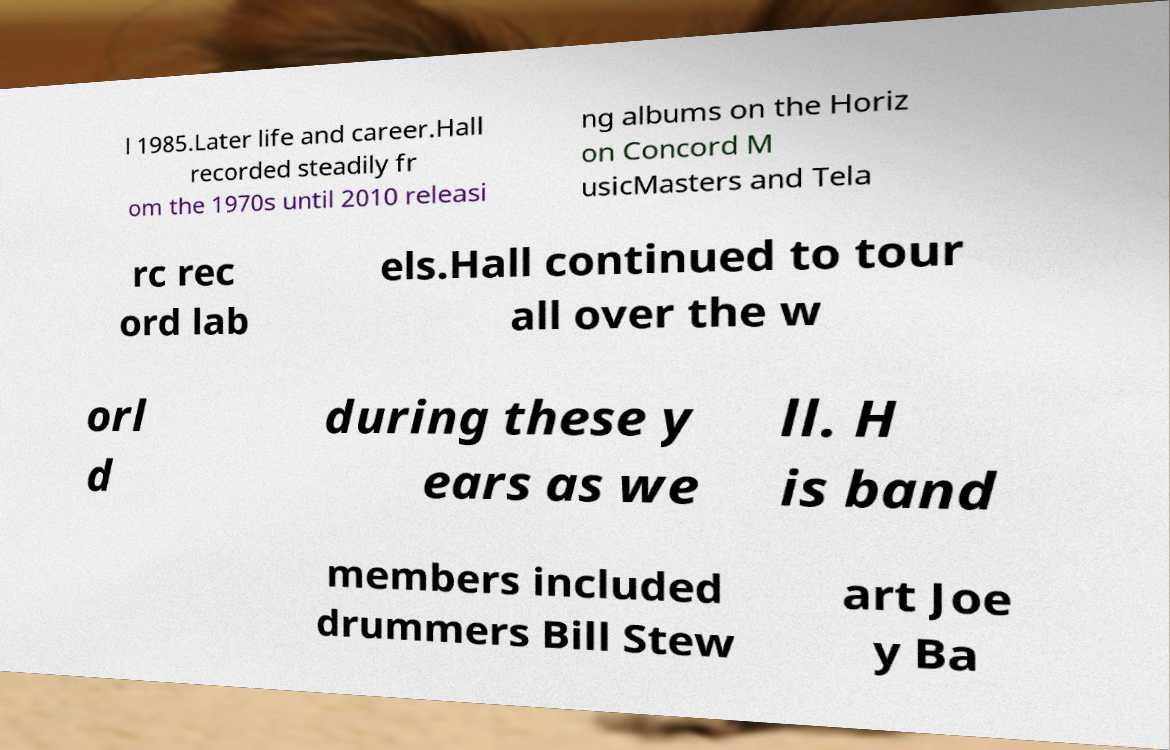Please identify and transcribe the text found in this image. l 1985.Later life and career.Hall recorded steadily fr om the 1970s until 2010 releasi ng albums on the Horiz on Concord M usicMasters and Tela rc rec ord lab els.Hall continued to tour all over the w orl d during these y ears as we ll. H is band members included drummers Bill Stew art Joe y Ba 